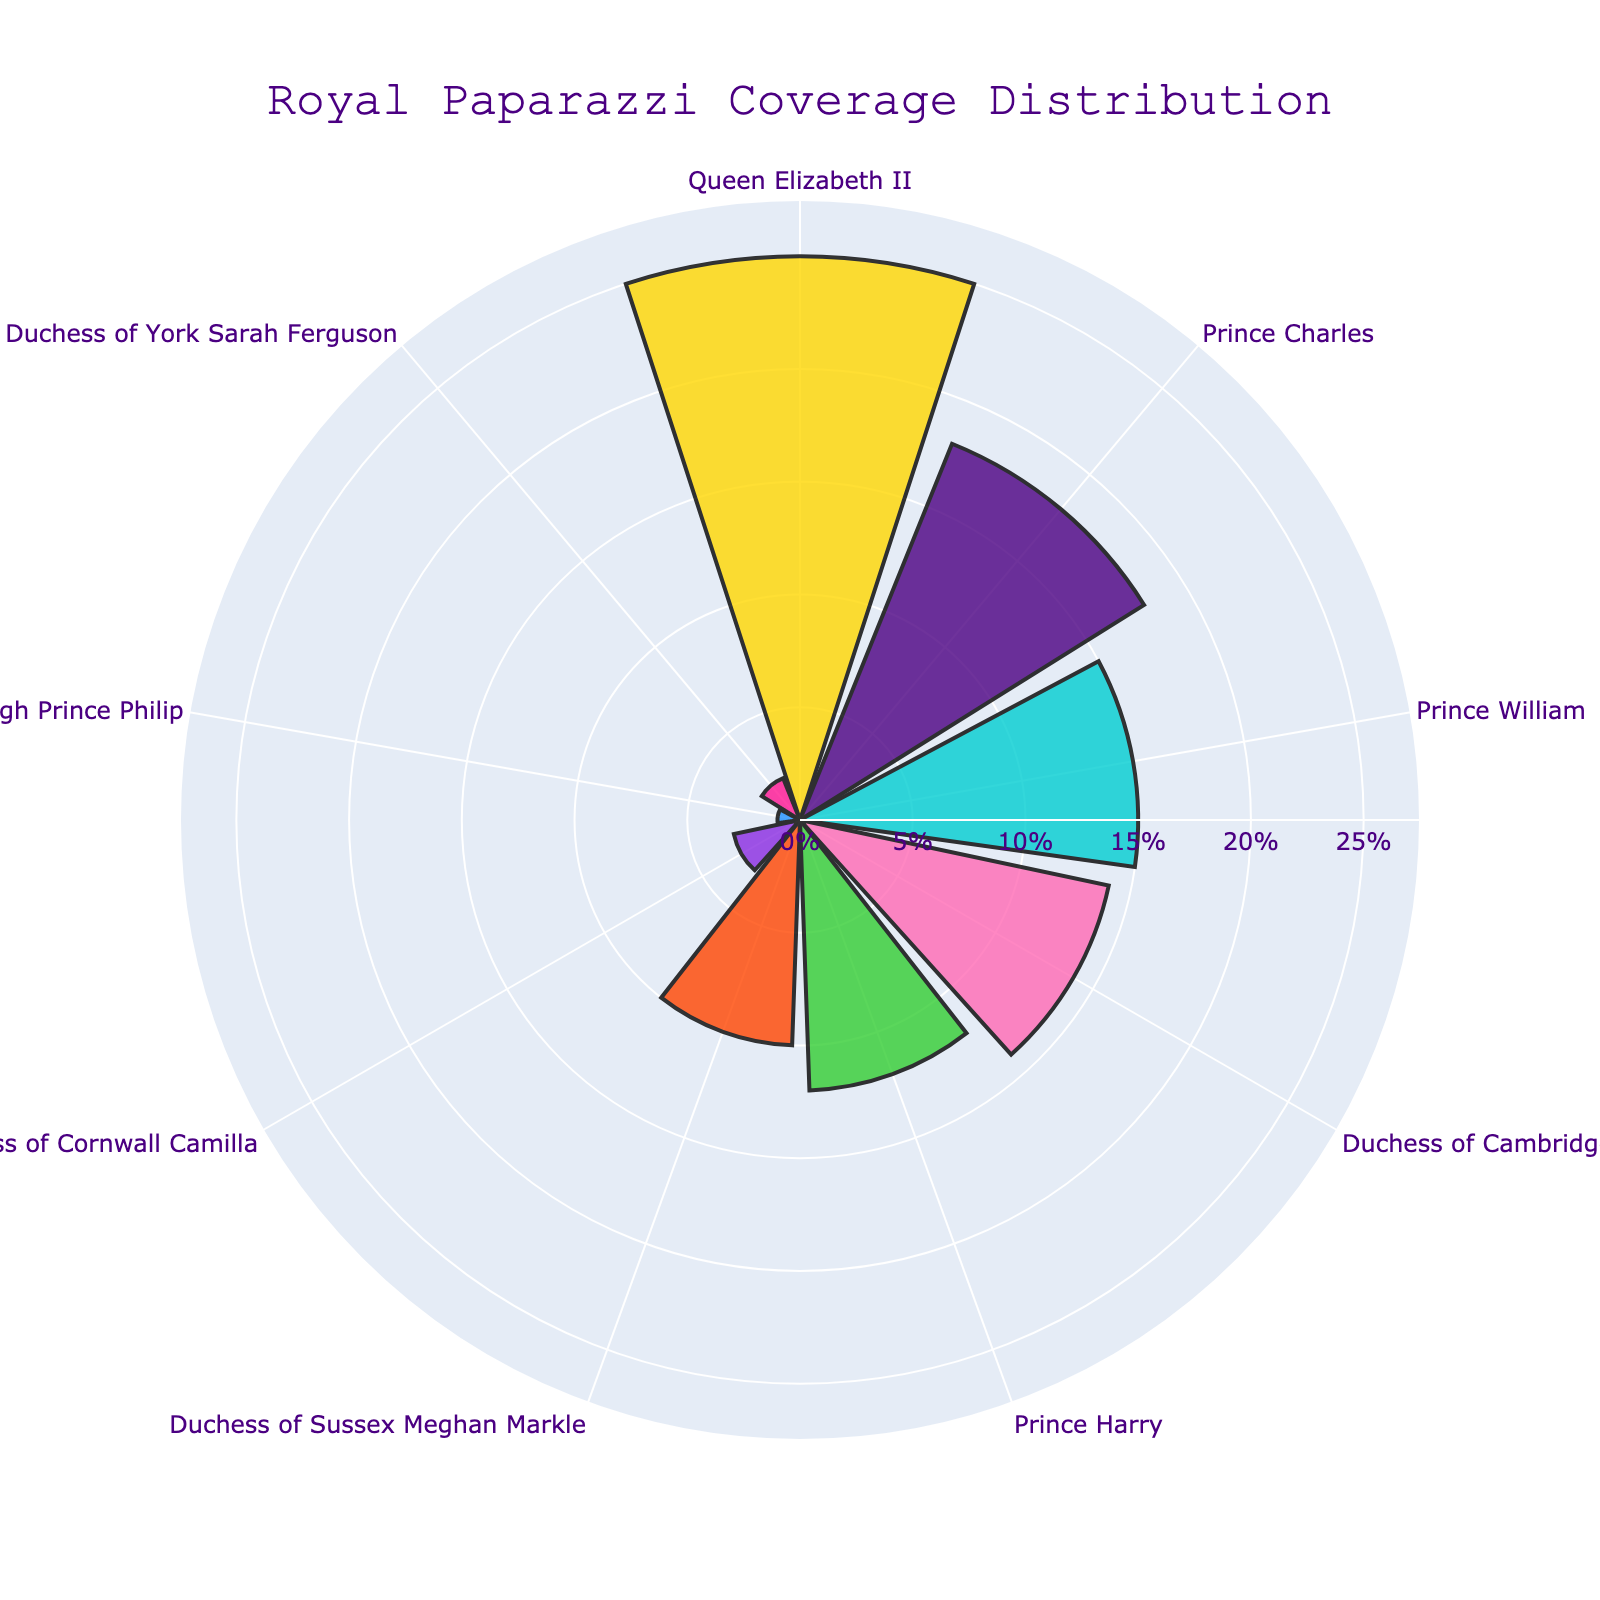Which royal family member receives the highest paparazzi coverage? The figure shows that Queen Elizabeth II has the largest section of the plot, representing 25% coverage, which is the highest among all members.
Answer: Queen Elizabeth II Which royal family members have a paparazzi coverage percentage of less than 5%? By examining the plot, we can see that Duchess of Cornwall Camilla, Duke of Edinburgh Prince Philip, and Duchess of York Sarah Ferguson have smaller sections, representing 3%, 1%, and 2% coverage, respectively.
Answer: Duchess of Cornwall Camilla, Duke of Edinburgh Prince Philip, Duchess of York Sarah Ferguson What's the total paparazzi coverage percentage for Queen Elizabeth II and Prince Charles combined? Adding the coverage percentages of Queen Elizabeth II (25%) and Prince Charles (18%) gives 25 + 18 = 43%.
Answer: 43% How much more paparazzi coverage does Duchess of Cambridge Kate Middleton have compared to Duchess of Sussex Meghan Markle? Subtracting Meghan Markle's coverage (10%) from Kate Middleton's coverage (14%) gives 14 - 10 = 4%.
Answer: 4% Who has slightly more paparazzi coverage, Duchess of Cambridge Kate Middleton or Prince Harry? Comparing the percentages, Kate Middleton has 14% coverage, while Prince Harry has 12%. Therefore, Kate Middleton has slightly more coverage.
Answer: Duchess of Cambridge Kate Middleton Which royal family members have a paparazzi coverage percentage between 10% and 20%? From the plot, the members with percentages in this range are Prince Charles (18%), Prince William (15%), Duchess of Cambridge Kate Middleton (14%), and Prince Harry (12%).
Answer: Prince Charles, Prince William, Duchess of Cambridge Kate Middleton, Prince Harry How many family members have a paparazzi coverage percentage of 10% or more? Counting the sections in the plot, there are six members with 10% or more coverage: Queen Elizabeth II (25%), Prince Charles (18%), Prince William (15%), Duchess of Cambridge Kate Middleton (14%), Prince Harry (12%), and Duchess of Sussex Meghan Markle (10%).
Answer: 6 What is the average paparazzi coverage percentage of the top three covered royal family members? The top three members are Queen Elizabeth II (25%), Prince Charles (18%), and Prince William (15%). The average is (25 + 18 + 15) / 3 = 58 / 3 ≈ 19.33%.
Answer: Approx. 19.33% Compare the combined paparazzi coverage percentage of Duchess of Cambridge Kate Middleton and Prince Harry to that of Duchess of Sussex Meghan Markle. Combining Kate Middleton's 14% and Prince Harry's 12% gives 14 + 12 = 26%. Meghan Markle has 10%. The combined coverage of Kate Middleton and Prince Harry (26%) is significantly higher than that of Meghan Markle (10%).
Answer: 26% to 10% 